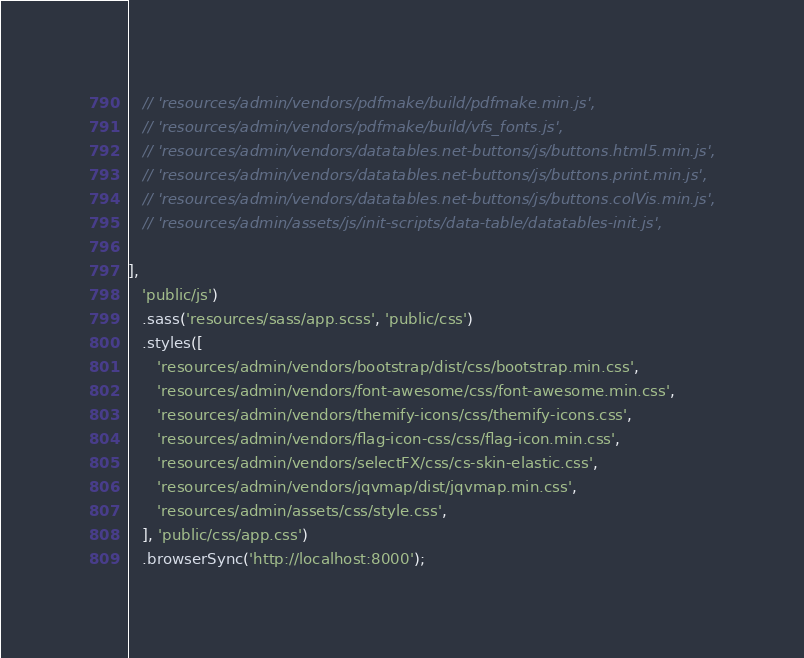Convert code to text. <code><loc_0><loc_0><loc_500><loc_500><_JavaScript_>   // 'resources/admin/vendors/pdfmake/build/pdfmake.min.js',
   // 'resources/admin/vendors/pdfmake/build/vfs_fonts.js',
   // 'resources/admin/vendors/datatables.net-buttons/js/buttons.html5.min.js',
   // 'resources/admin/vendors/datatables.net-buttons/js/buttons.print.min.js',
   // 'resources/admin/vendors/datatables.net-buttons/js/buttons.colVis.min.js',
   // 'resources/admin/assets/js/init-scripts/data-table/datatables-init.js',

],
   'public/js')
   .sass('resources/sass/app.scss', 'public/css')
   .styles([
      'resources/admin/vendors/bootstrap/dist/css/bootstrap.min.css',
      'resources/admin/vendors/font-awesome/css/font-awesome.min.css',
      'resources/admin/vendors/themify-icons/css/themify-icons.css',
      'resources/admin/vendors/flag-icon-css/css/flag-icon.min.css',
      'resources/admin/vendors/selectFX/css/cs-skin-elastic.css',
      'resources/admin/vendors/jqvmap/dist/jqvmap.min.css',
      'resources/admin/assets/css/style.css',
   ], 'public/css/app.css')
   .browserSync('http://localhost:8000');</code> 